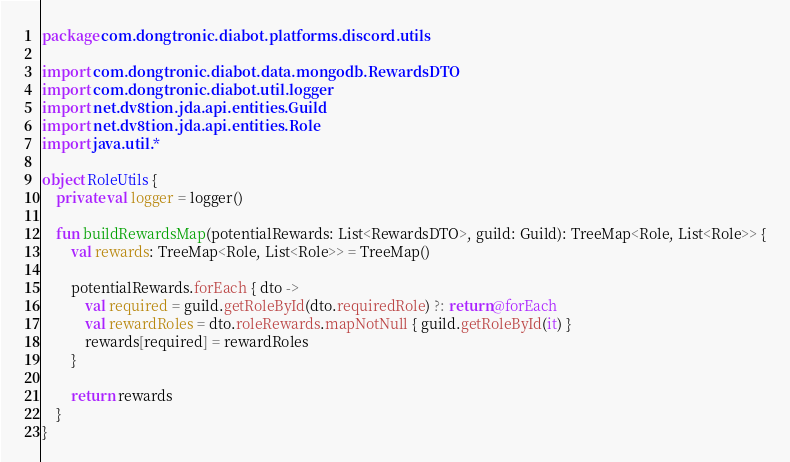Convert code to text. <code><loc_0><loc_0><loc_500><loc_500><_Kotlin_>package com.dongtronic.diabot.platforms.discord.utils

import com.dongtronic.diabot.data.mongodb.RewardsDTO
import com.dongtronic.diabot.util.logger
import net.dv8tion.jda.api.entities.Guild
import net.dv8tion.jda.api.entities.Role
import java.util.*

object RoleUtils {
    private val logger = logger()

    fun buildRewardsMap(potentialRewards: List<RewardsDTO>, guild: Guild): TreeMap<Role, List<Role>> {
        val rewards: TreeMap<Role, List<Role>> = TreeMap()

        potentialRewards.forEach { dto ->
            val required = guild.getRoleById(dto.requiredRole) ?: return@forEach
            val rewardRoles = dto.roleRewards.mapNotNull { guild.getRoleById(it) }
            rewards[required] = rewardRoles
        }

        return rewards
    }
}
</code> 